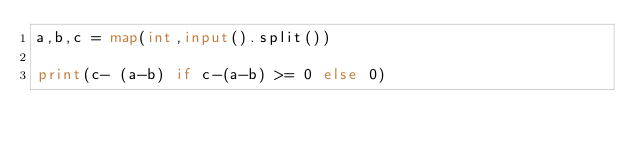Convert code to text. <code><loc_0><loc_0><loc_500><loc_500><_Python_>a,b,c = map(int,input().split())

print(c- (a-b) if c-(a-b) >= 0 else 0)</code> 